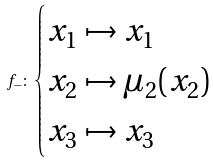<formula> <loc_0><loc_0><loc_500><loc_500>f _ { - } \colon \begin{cases} x _ { 1 } \mapsto x _ { 1 } \\ x _ { 2 } \mapsto \mu _ { 2 } ( x _ { 2 } ) \\ x _ { 3 } \mapsto x _ { 3 } \end{cases}</formula> 